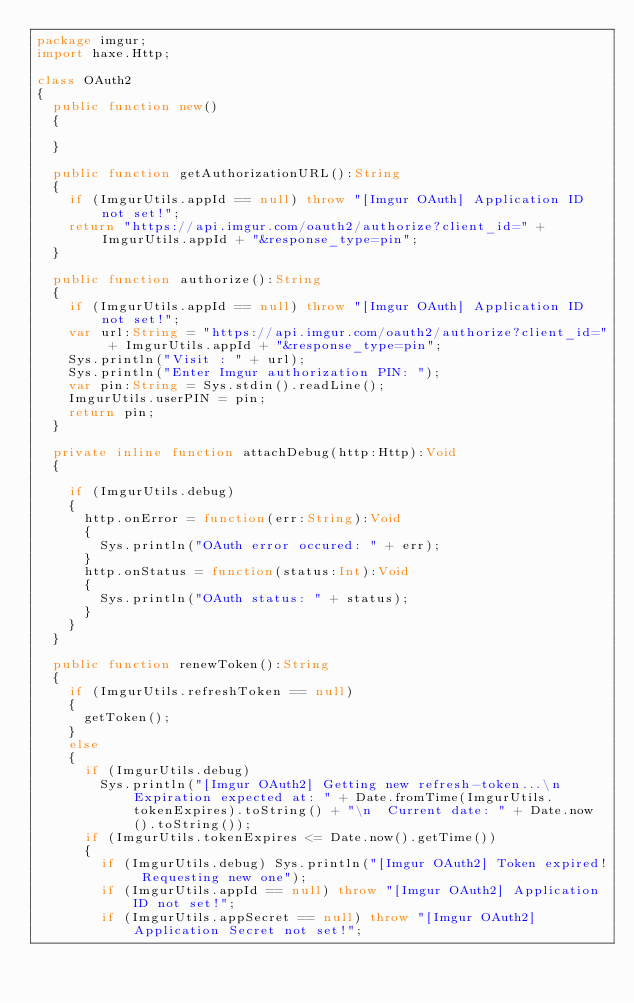Convert code to text. <code><loc_0><loc_0><loc_500><loc_500><_Haxe_>package imgur;
import haxe.Http;

class OAuth2
{
  public function new()
  {
    
  }
  
  public function getAuthorizationURL():String
  {
    if (ImgurUtils.appId == null) throw "[Imgur OAuth] Application ID not set!";
    return "https://api.imgur.com/oauth2/authorize?client_id=" + ImgurUtils.appId + "&response_type=pin";
  }
  
  public function authorize():String
  {
    if (ImgurUtils.appId == null) throw "[Imgur OAuth] Application ID not set!";
    var url:String = "https://api.imgur.com/oauth2/authorize?client_id=" + ImgurUtils.appId + "&response_type=pin";
    Sys.println("Visit : " + url);
    Sys.println("Enter Imgur authorization PIN: ");
    var pin:String = Sys.stdin().readLine();
    ImgurUtils.userPIN = pin;
    return pin;
  }
  
  private inline function attachDebug(http:Http):Void
  {
    
    if (ImgurUtils.debug)
    {
      http.onError = function(err:String):Void
      {
        Sys.println("OAuth error occured: " + err);
      }
      http.onStatus = function(status:Int):Void
      {
        Sys.println("OAuth status: " + status);
      }
    }
  }
  
  public function renewToken():String
  {
    if (ImgurUtils.refreshToken == null)
    {
      getToken();
    }
    else
    {
      if (ImgurUtils.debug)
        Sys.println("[Imgur OAuth2] Getting new refresh-token...\n  Expiration expected at: " + Date.fromTime(ImgurUtils.tokenExpires).toString() + "\n  Current date: " + Date.now().toString());
      if (ImgurUtils.tokenExpires <= Date.now().getTime())
      {
        if (ImgurUtils.debug) Sys.println("[Imgur OAuth2] Token expired! Requesting new one");
        if (ImgurUtils.appId == null) throw "[Imgur OAuth2] Application ID not set!";
        if (ImgurUtils.appSecret == null) throw "[Imgur OAuth2] Application Secret not set!";</code> 